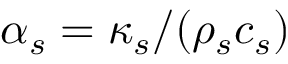Convert formula to latex. <formula><loc_0><loc_0><loc_500><loc_500>\alpha _ { s } = \kappa _ { s } / ( \rho _ { s } c _ { s } )</formula> 